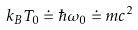<formula> <loc_0><loc_0><loc_500><loc_500>k _ { B } T _ { 0 } \doteq \hbar { \omega } _ { 0 } \doteq m c ^ { 2 }</formula> 